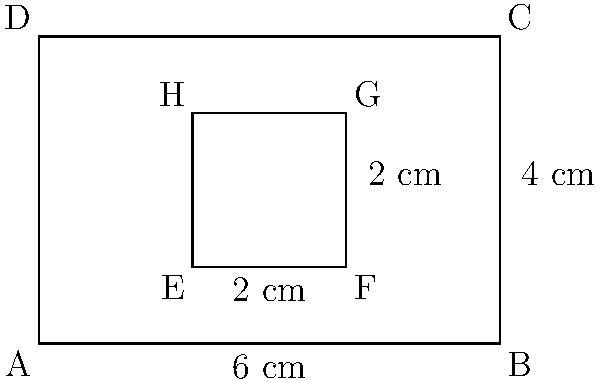A local cinema is offering budget-friendly poster framing options for film enthusiasts. The outer rectangle ABCD represents a standard poster frame, while the inner rectangle EFGH is the visible area of the poster after framing. If the outer frame has dimensions of 6 cm by 4 cm, and the visible area is congruent to a rectangle with dimensions that are $\frac{1}{3}$ of the outer frame's dimensions, what is the area of the visible poster in square centimeters? Let's approach this step-by-step:

1) The outer frame ABCD has dimensions of 6 cm by 4 cm.

2) The visible area EFGH is congruent to a rectangle with dimensions that are $\frac{1}{3}$ of the outer frame's dimensions.

3) To find the dimensions of EFGH:
   - Width of EFGH = $\frac{1}{3} \times 6$ cm = 2 cm
   - Height of EFGH = $\frac{1}{3} \times 4$ cm = $\frac{4}{3}$ cm

4) Now, to calculate the area of the visible poster (EFGH):
   Area = width $\times$ height
   Area = 2 cm $\times \frac{4}{3}$ cm = $\frac{8}{3}$ cm²

5) Simplifying the fraction:
   $\frac{8}{3}$ = $2\frac{2}{3}$ cm²

Therefore, the area of the visible poster is $2\frac{2}{3}$ square centimeters.
Answer: $2\frac{2}{3}$ cm² 